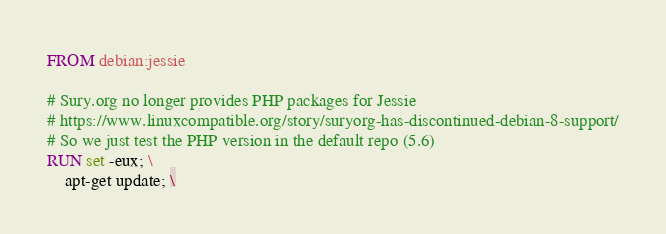<code> <loc_0><loc_0><loc_500><loc_500><_Dockerfile_>FROM debian:jessie

# Sury.org no longer provides PHP packages for Jessie
# https://www.linuxcompatible.org/story/suryorg-has-discontinued-debian-8-support/
# So we just test the PHP version in the default repo (5.6)
RUN set -eux; \
    apt-get update; \</code> 